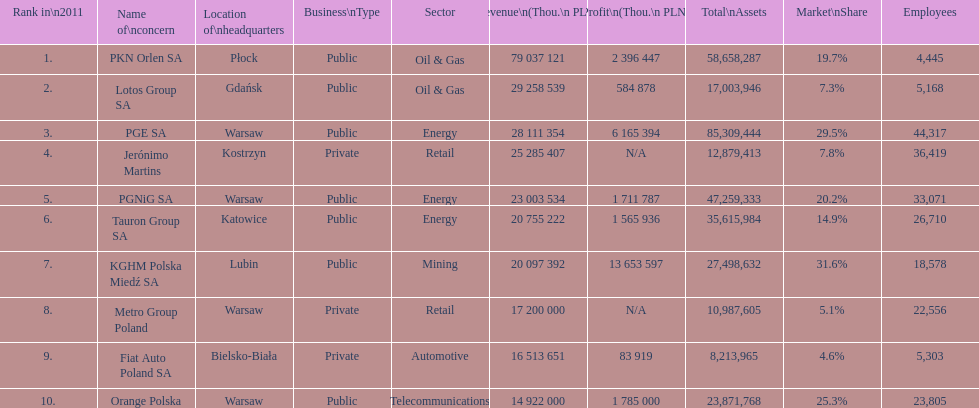What company is the only one with a revenue greater than 75,000,000 thou. pln? PKN Orlen SA. 